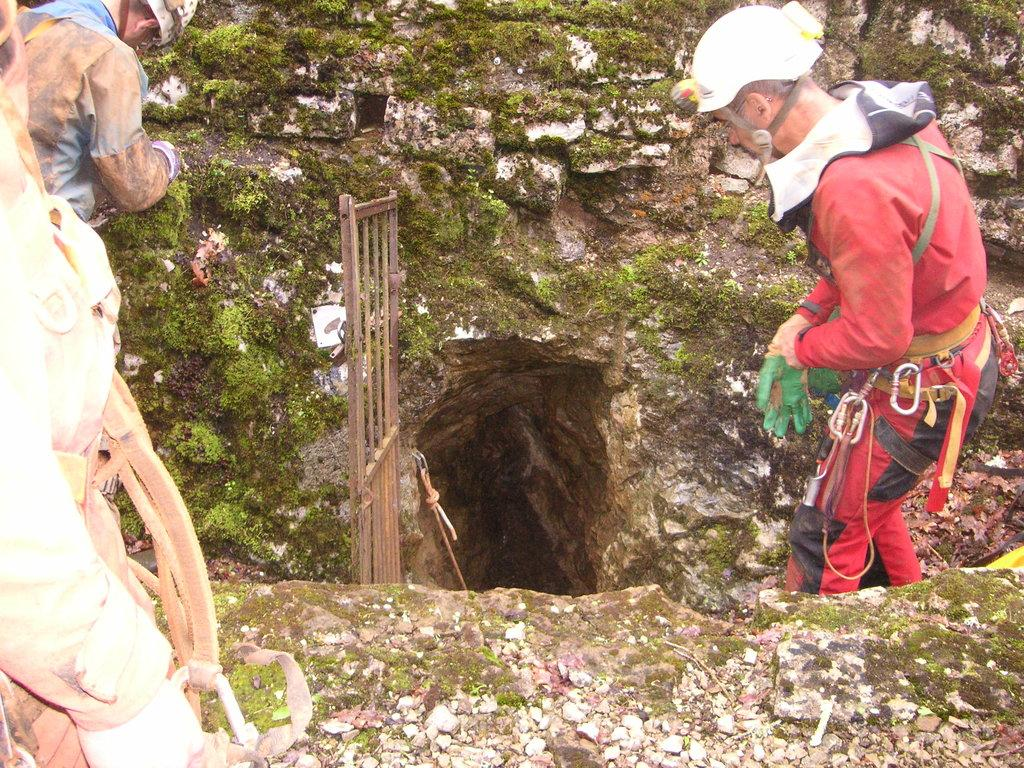What type of natural formation can be seen in the image? There is a cave in the image. What structure is present near the cave? There is a gate in the image. What object can be used for climbing or pulling in the image? There is a rope in the image. Who or what is present in the image? There are people in the image. What type of growth can be seen on the cave walls or floor in the image? There is green fungus in the image. What type of mouth can be seen on the cave in the image? There is no mouth present on the cave in the image. How does the fungus laugh in the image? The fungus does not laugh in the image, as it is a non-living organism and does not have the ability to laugh. 